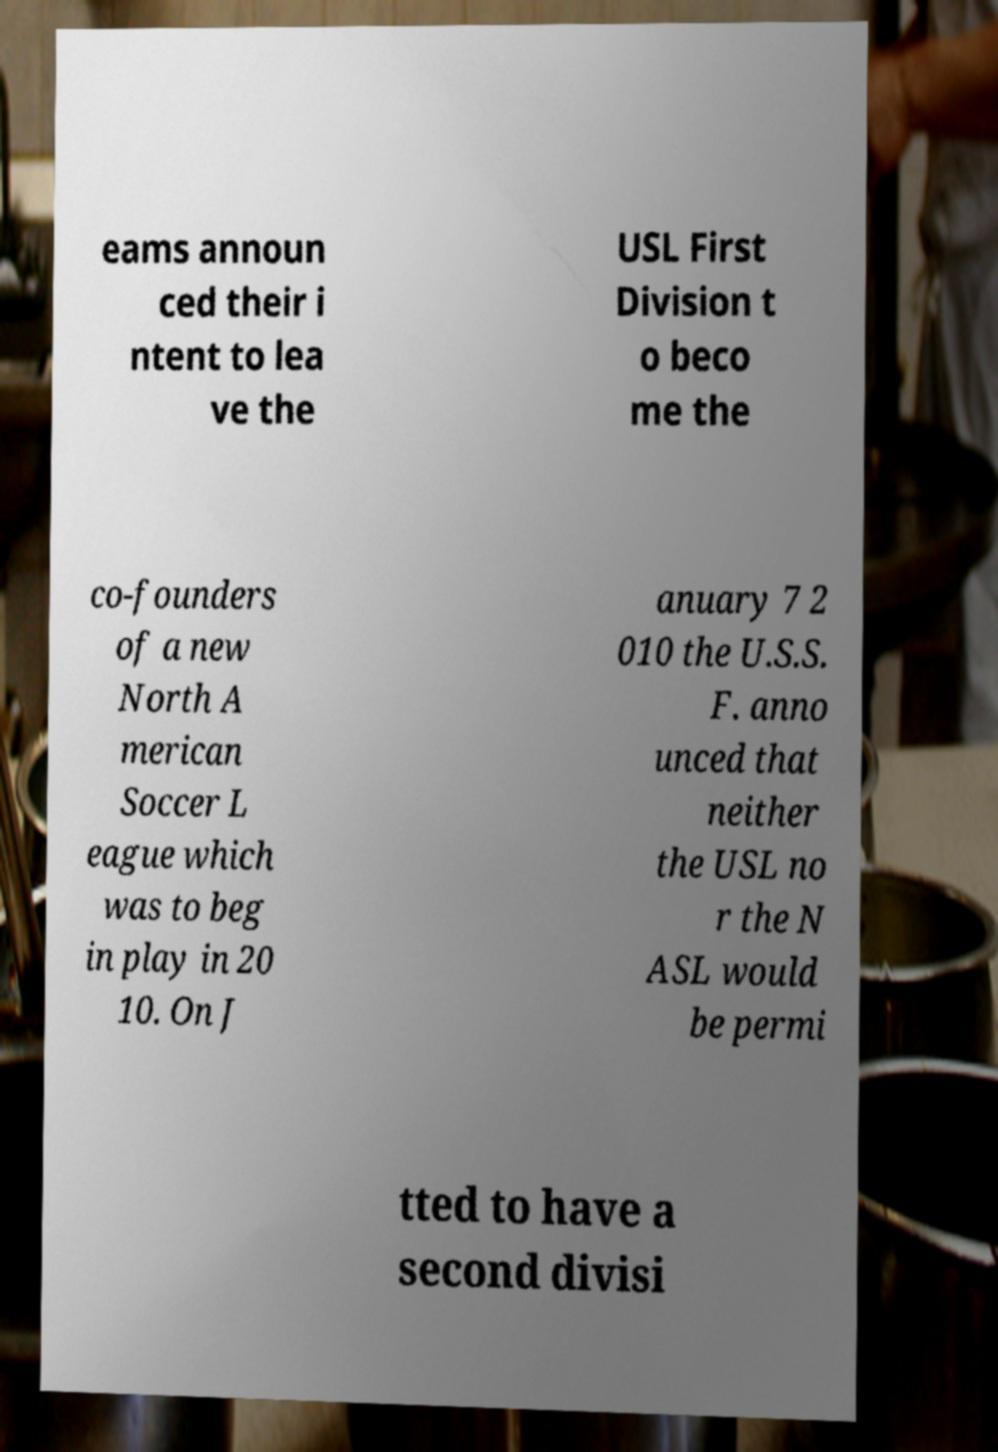Please identify and transcribe the text found in this image. eams announ ced their i ntent to lea ve the USL First Division t o beco me the co-founders of a new North A merican Soccer L eague which was to beg in play in 20 10. On J anuary 7 2 010 the U.S.S. F. anno unced that neither the USL no r the N ASL would be permi tted to have a second divisi 